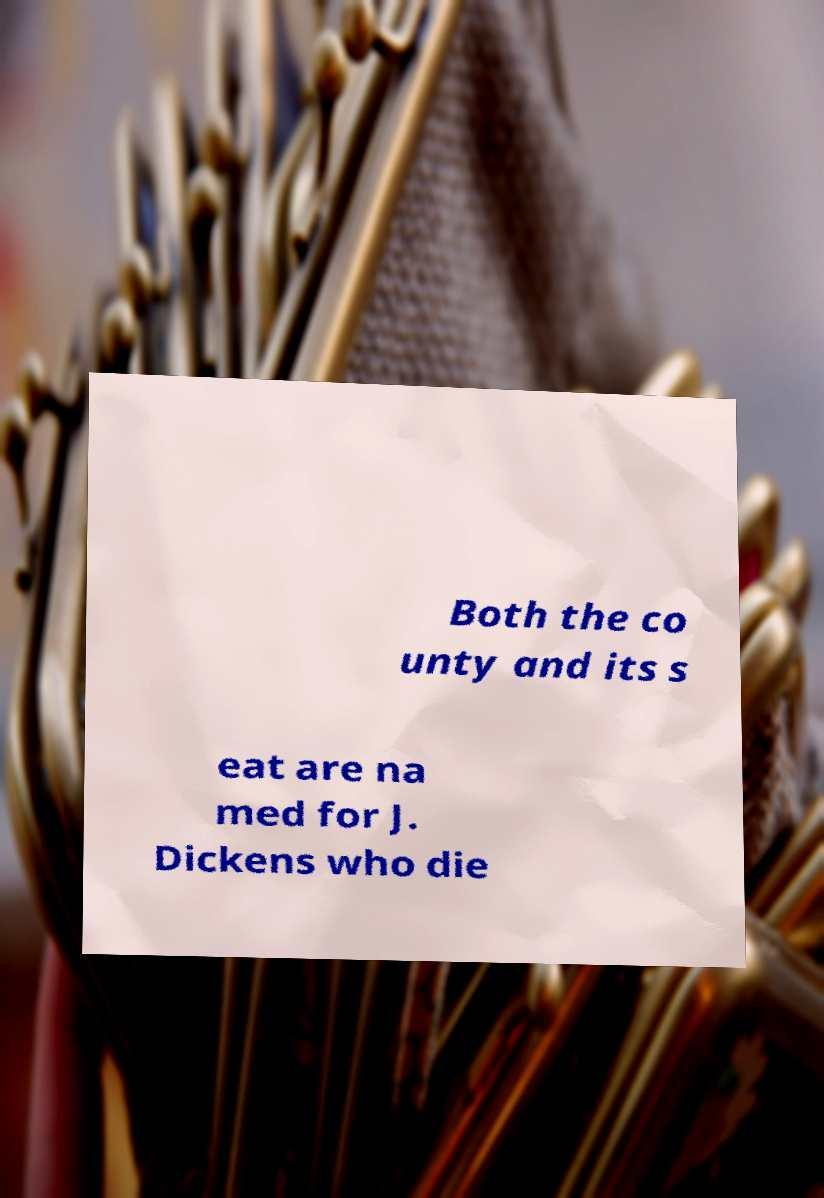Can you accurately transcribe the text from the provided image for me? Both the co unty and its s eat are na med for J. Dickens who die 